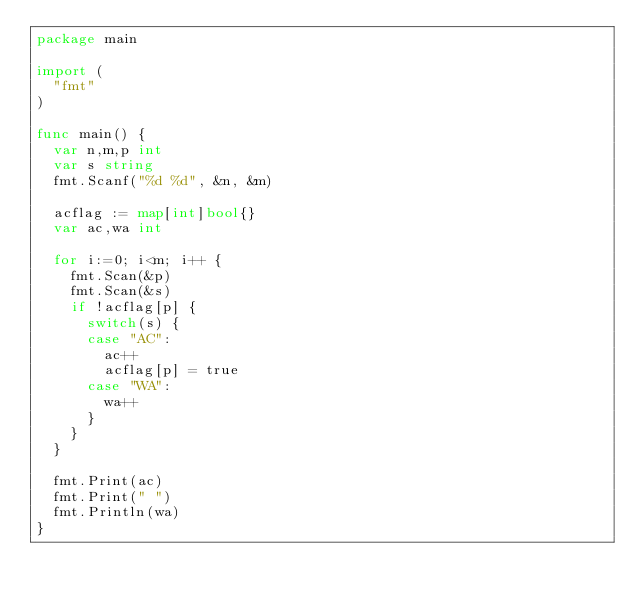<code> <loc_0><loc_0><loc_500><loc_500><_Go_>package main

import (
  "fmt"
)

func main() {
  var n,m,p int
  var s string
  fmt.Scanf("%d %d", &n, &m)

  acflag := map[int]bool{}
  var ac,wa int

  for i:=0; i<m; i++ {
    fmt.Scan(&p)
    fmt.Scan(&s)
    if !acflag[p] {
      switch(s) {
      case "AC":
        ac++
        acflag[p] = true
      case "WA":
        wa++
      }
    }
  }

  fmt.Print(ac)
  fmt.Print(" ")
  fmt.Println(wa)
}
</code> 